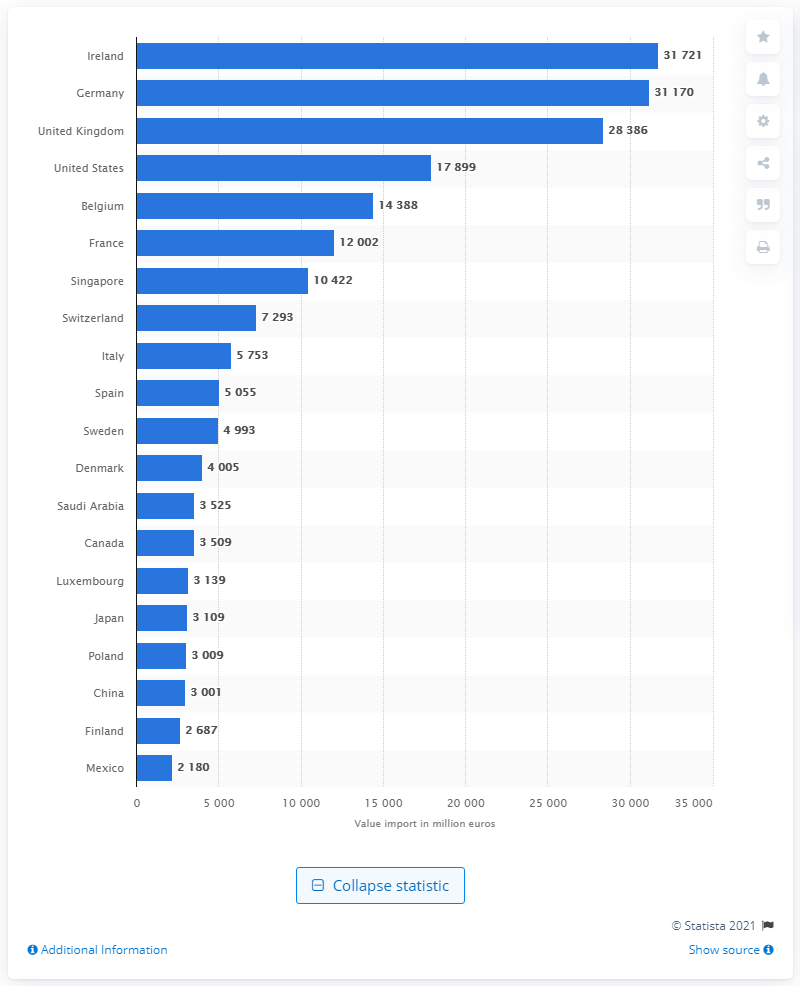Point out several critical features in this image. The value of service exports to the United States in the same year was 17,899. In 2019, the value of services exported to both Ireland and Germany was 31,170... 